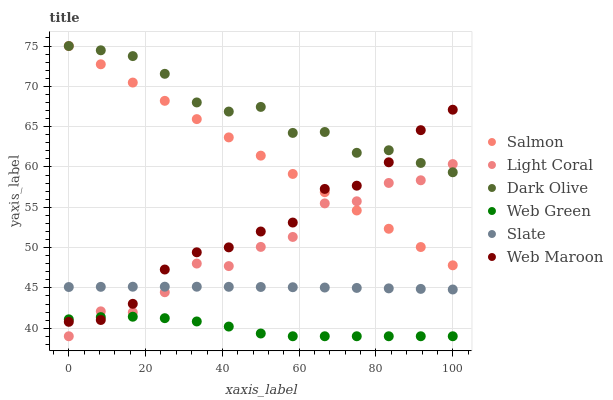Does Web Green have the minimum area under the curve?
Answer yes or no. Yes. Does Dark Olive have the maximum area under the curve?
Answer yes or no. Yes. Does Slate have the minimum area under the curve?
Answer yes or no. No. Does Slate have the maximum area under the curve?
Answer yes or no. No. Is Salmon the smoothest?
Answer yes or no. Yes. Is Light Coral the roughest?
Answer yes or no. Yes. Is Slate the smoothest?
Answer yes or no. No. Is Slate the roughest?
Answer yes or no. No. Does Web Green have the lowest value?
Answer yes or no. Yes. Does Slate have the lowest value?
Answer yes or no. No. Does Dark Olive have the highest value?
Answer yes or no. Yes. Does Slate have the highest value?
Answer yes or no. No. Is Web Green less than Slate?
Answer yes or no. Yes. Is Salmon greater than Web Green?
Answer yes or no. Yes. Does Light Coral intersect Web Green?
Answer yes or no. Yes. Is Light Coral less than Web Green?
Answer yes or no. No. Is Light Coral greater than Web Green?
Answer yes or no. No. Does Web Green intersect Slate?
Answer yes or no. No. 